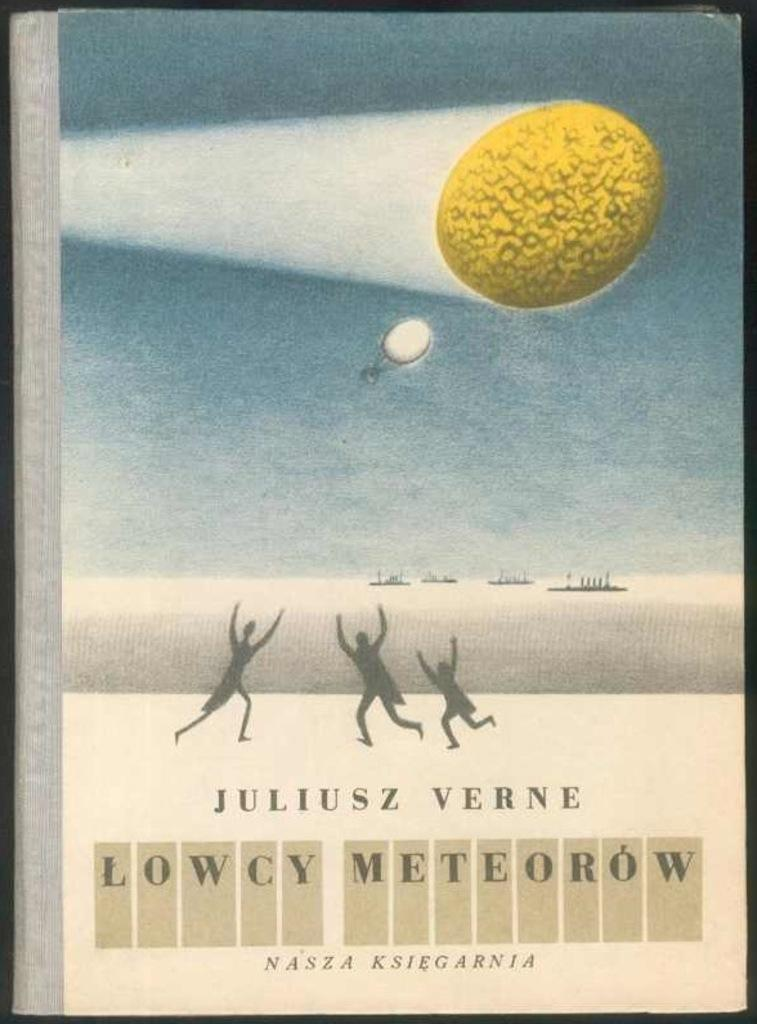What is present in the image related to reading material? There is a book in the image. What type of content is on the book? The book has pictures and text on it. Where is the book located in the image? The book is placed on a surface. What type of advice can be heard coming from the book in the image? The book does not produce sound or give advice in the image; it is a static object with pictures and text. 